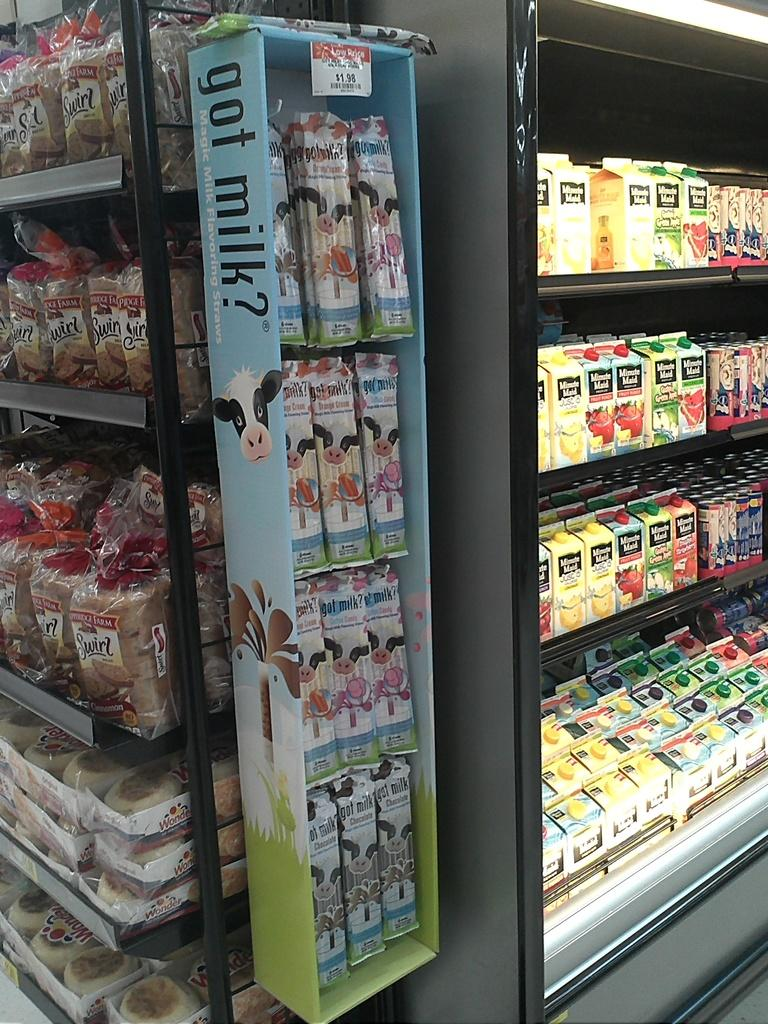Provide a one-sentence caption for the provided image. A box outside the cooler says got milk? on the side. 